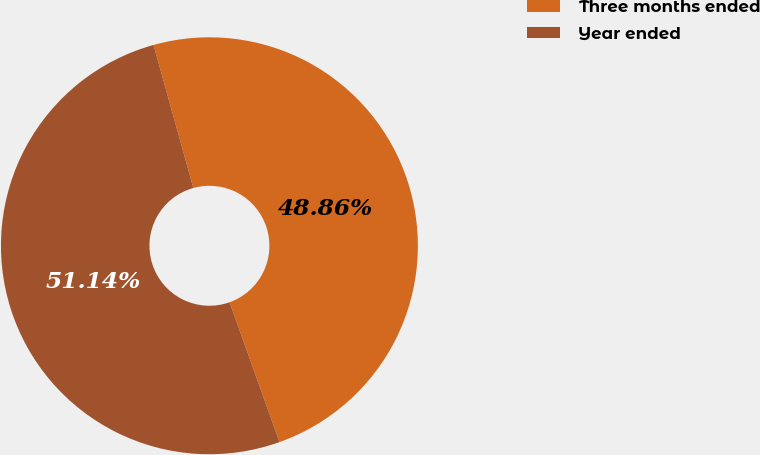<chart> <loc_0><loc_0><loc_500><loc_500><pie_chart><fcel>Three months ended<fcel>Year ended<nl><fcel>48.86%<fcel>51.14%<nl></chart> 